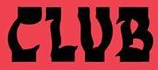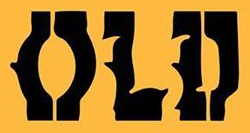Identify the words shown in these images in order, separated by a semicolon. CLUB; OLD 